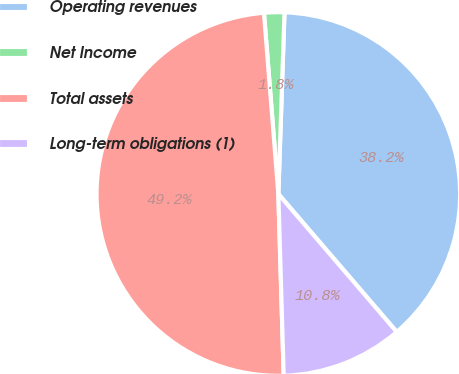<chart> <loc_0><loc_0><loc_500><loc_500><pie_chart><fcel>Operating revenues<fcel>Net Income<fcel>Total assets<fcel>Long-term obligations (1)<nl><fcel>38.17%<fcel>1.8%<fcel>49.2%<fcel>10.82%<nl></chart> 